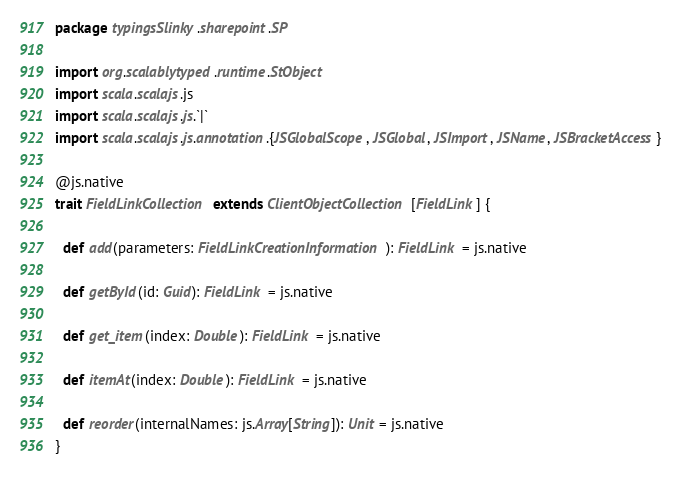<code> <loc_0><loc_0><loc_500><loc_500><_Scala_>package typingsSlinky.sharepoint.SP

import org.scalablytyped.runtime.StObject
import scala.scalajs.js
import scala.scalajs.js.`|`
import scala.scalajs.js.annotation.{JSGlobalScope, JSGlobal, JSImport, JSName, JSBracketAccess}

@js.native
trait FieldLinkCollection extends ClientObjectCollection[FieldLink] {
  
  def add(parameters: FieldLinkCreationInformation): FieldLink = js.native
  
  def getById(id: Guid): FieldLink = js.native
  
  def get_item(index: Double): FieldLink = js.native
  
  def itemAt(index: Double): FieldLink = js.native
  
  def reorder(internalNames: js.Array[String]): Unit = js.native
}
</code> 